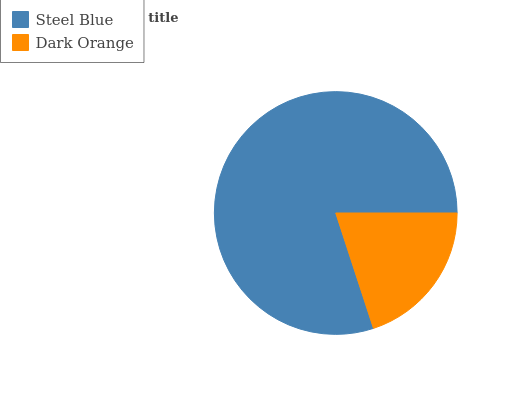Is Dark Orange the minimum?
Answer yes or no. Yes. Is Steel Blue the maximum?
Answer yes or no. Yes. Is Dark Orange the maximum?
Answer yes or no. No. Is Steel Blue greater than Dark Orange?
Answer yes or no. Yes. Is Dark Orange less than Steel Blue?
Answer yes or no. Yes. Is Dark Orange greater than Steel Blue?
Answer yes or no. No. Is Steel Blue less than Dark Orange?
Answer yes or no. No. Is Steel Blue the high median?
Answer yes or no. Yes. Is Dark Orange the low median?
Answer yes or no. Yes. Is Dark Orange the high median?
Answer yes or no. No. Is Steel Blue the low median?
Answer yes or no. No. 